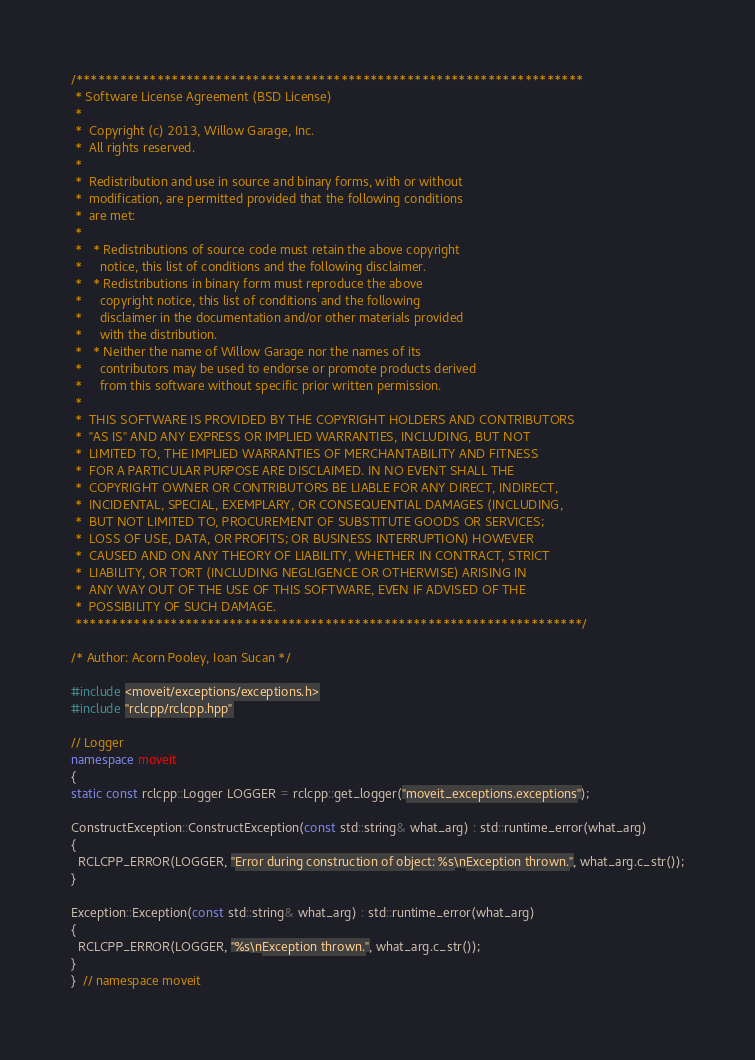<code> <loc_0><loc_0><loc_500><loc_500><_C++_>/*********************************************************************
 * Software License Agreement (BSD License)
 *
 *  Copyright (c) 2013, Willow Garage, Inc.
 *  All rights reserved.
 *
 *  Redistribution and use in source and binary forms, with or without
 *  modification, are permitted provided that the following conditions
 *  are met:
 *
 *   * Redistributions of source code must retain the above copyright
 *     notice, this list of conditions and the following disclaimer.
 *   * Redistributions in binary form must reproduce the above
 *     copyright notice, this list of conditions and the following
 *     disclaimer in the documentation and/or other materials provided
 *     with the distribution.
 *   * Neither the name of Willow Garage nor the names of its
 *     contributors may be used to endorse or promote products derived
 *     from this software without specific prior written permission.
 *
 *  THIS SOFTWARE IS PROVIDED BY THE COPYRIGHT HOLDERS AND CONTRIBUTORS
 *  "AS IS" AND ANY EXPRESS OR IMPLIED WARRANTIES, INCLUDING, BUT NOT
 *  LIMITED TO, THE IMPLIED WARRANTIES OF MERCHANTABILITY AND FITNESS
 *  FOR A PARTICULAR PURPOSE ARE DISCLAIMED. IN NO EVENT SHALL THE
 *  COPYRIGHT OWNER OR CONTRIBUTORS BE LIABLE FOR ANY DIRECT, INDIRECT,
 *  INCIDENTAL, SPECIAL, EXEMPLARY, OR CONSEQUENTIAL DAMAGES (INCLUDING,
 *  BUT NOT LIMITED TO, PROCUREMENT OF SUBSTITUTE GOODS OR SERVICES;
 *  LOSS OF USE, DATA, OR PROFITS; OR BUSINESS INTERRUPTION) HOWEVER
 *  CAUSED AND ON ANY THEORY OF LIABILITY, WHETHER IN CONTRACT, STRICT
 *  LIABILITY, OR TORT (INCLUDING NEGLIGENCE OR OTHERWISE) ARISING IN
 *  ANY WAY OUT OF THE USE OF THIS SOFTWARE, EVEN IF ADVISED OF THE
 *  POSSIBILITY OF SUCH DAMAGE.
 *********************************************************************/

/* Author: Acorn Pooley, Ioan Sucan */

#include <moveit/exceptions/exceptions.h>
#include "rclcpp/rclcpp.hpp"

// Logger
namespace moveit
{
static const rclcpp::Logger LOGGER = rclcpp::get_logger("moveit_exceptions.exceptions");

ConstructException::ConstructException(const std::string& what_arg) : std::runtime_error(what_arg)
{
  RCLCPP_ERROR(LOGGER, "Error during construction of object: %s\nException thrown.", what_arg.c_str());
}

Exception::Exception(const std::string& what_arg) : std::runtime_error(what_arg)
{
  RCLCPP_ERROR(LOGGER, "%s\nException thrown.", what_arg.c_str());
}
}  // namespace moveit
</code> 